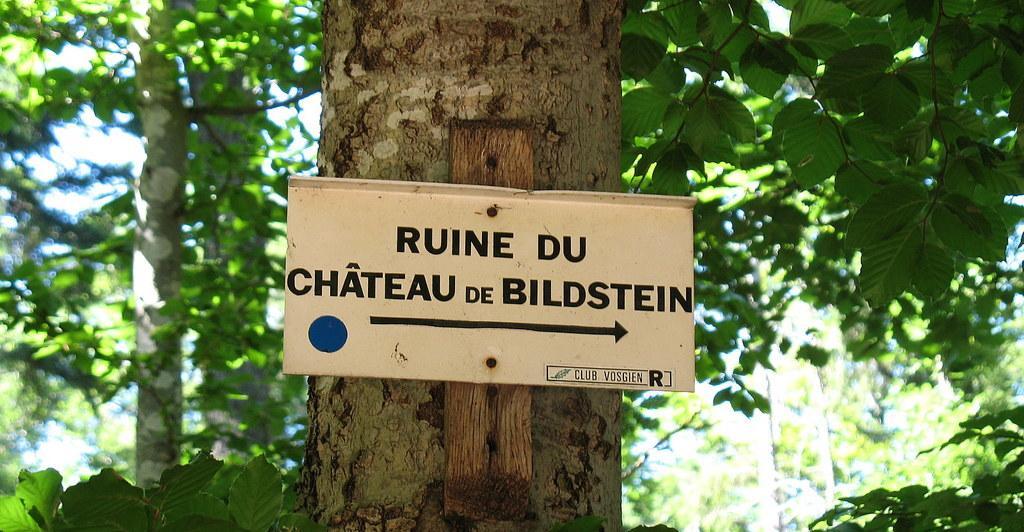Describe this image in one or two sentences. In the image there is a name board on a tree and behind there are many trees. 